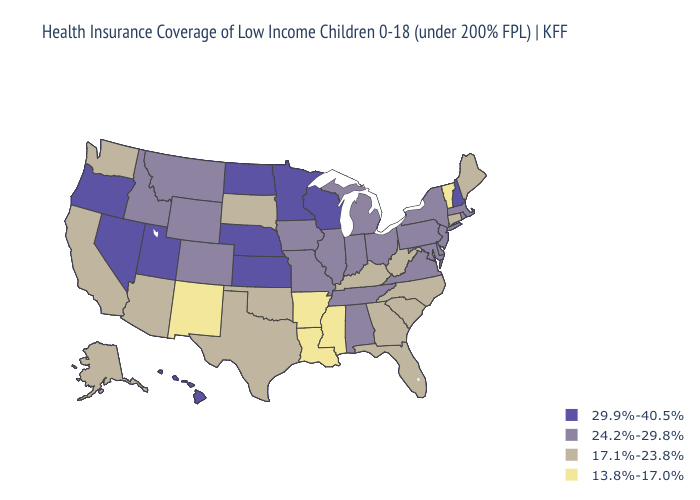What is the value of Colorado?
Keep it brief. 24.2%-29.8%. Does Wisconsin have the highest value in the USA?
Short answer required. Yes. Name the states that have a value in the range 24.2%-29.8%?
Give a very brief answer. Alabama, Colorado, Delaware, Idaho, Illinois, Indiana, Iowa, Maryland, Massachusetts, Michigan, Missouri, Montana, New Jersey, New York, Ohio, Pennsylvania, Rhode Island, Tennessee, Virginia, Wyoming. What is the highest value in states that border Virginia?
Short answer required. 24.2%-29.8%. Name the states that have a value in the range 17.1%-23.8%?
Give a very brief answer. Alaska, Arizona, California, Connecticut, Florida, Georgia, Kentucky, Maine, North Carolina, Oklahoma, South Carolina, South Dakota, Texas, Washington, West Virginia. Does Alabama have the same value as Alaska?
Keep it brief. No. Name the states that have a value in the range 24.2%-29.8%?
Short answer required. Alabama, Colorado, Delaware, Idaho, Illinois, Indiana, Iowa, Maryland, Massachusetts, Michigan, Missouri, Montana, New Jersey, New York, Ohio, Pennsylvania, Rhode Island, Tennessee, Virginia, Wyoming. Is the legend a continuous bar?
Short answer required. No. Among the states that border Arizona , does Utah have the highest value?
Write a very short answer. Yes. Does the first symbol in the legend represent the smallest category?
Concise answer only. No. Name the states that have a value in the range 24.2%-29.8%?
Keep it brief. Alabama, Colorado, Delaware, Idaho, Illinois, Indiana, Iowa, Maryland, Massachusetts, Michigan, Missouri, Montana, New Jersey, New York, Ohio, Pennsylvania, Rhode Island, Tennessee, Virginia, Wyoming. What is the value of Rhode Island?
Give a very brief answer. 24.2%-29.8%. Which states hav the highest value in the Northeast?
Answer briefly. New Hampshire. Does Massachusetts have the lowest value in the USA?
Give a very brief answer. No. Which states have the highest value in the USA?
Write a very short answer. Hawaii, Kansas, Minnesota, Nebraska, Nevada, New Hampshire, North Dakota, Oregon, Utah, Wisconsin. 